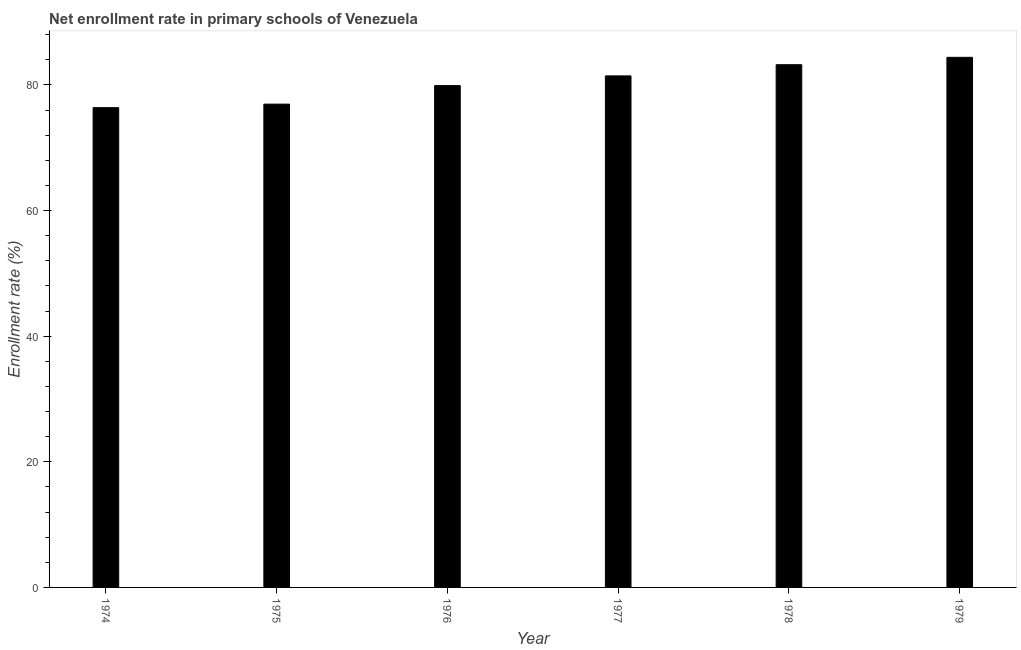Does the graph contain any zero values?
Provide a succinct answer. No. What is the title of the graph?
Your response must be concise. Net enrollment rate in primary schools of Venezuela. What is the label or title of the X-axis?
Give a very brief answer. Year. What is the label or title of the Y-axis?
Provide a short and direct response. Enrollment rate (%). What is the net enrollment rate in primary schools in 1974?
Your answer should be very brief. 76.38. Across all years, what is the maximum net enrollment rate in primary schools?
Provide a succinct answer. 84.39. Across all years, what is the minimum net enrollment rate in primary schools?
Give a very brief answer. 76.38. In which year was the net enrollment rate in primary schools maximum?
Ensure brevity in your answer.  1979. In which year was the net enrollment rate in primary schools minimum?
Provide a succinct answer. 1974. What is the sum of the net enrollment rate in primary schools?
Give a very brief answer. 482.26. What is the difference between the net enrollment rate in primary schools in 1975 and 1979?
Ensure brevity in your answer.  -7.45. What is the average net enrollment rate in primary schools per year?
Ensure brevity in your answer.  80.38. What is the median net enrollment rate in primary schools?
Your answer should be compact. 80.66. In how many years, is the net enrollment rate in primary schools greater than 68 %?
Ensure brevity in your answer.  6. Do a majority of the years between 1976 and 1979 (inclusive) have net enrollment rate in primary schools greater than 12 %?
Keep it short and to the point. Yes. Is the net enrollment rate in primary schools in 1976 less than that in 1977?
Offer a terse response. Yes. What is the difference between the highest and the second highest net enrollment rate in primary schools?
Ensure brevity in your answer.  1.18. Is the sum of the net enrollment rate in primary schools in 1978 and 1979 greater than the maximum net enrollment rate in primary schools across all years?
Offer a terse response. Yes. What is the difference between the highest and the lowest net enrollment rate in primary schools?
Your answer should be very brief. 8.01. In how many years, is the net enrollment rate in primary schools greater than the average net enrollment rate in primary schools taken over all years?
Make the answer very short. 3. How many bars are there?
Your response must be concise. 6. Are all the bars in the graph horizontal?
Give a very brief answer. No. What is the Enrollment rate (%) of 1974?
Your response must be concise. 76.38. What is the Enrollment rate (%) of 1975?
Ensure brevity in your answer.  76.94. What is the Enrollment rate (%) of 1976?
Provide a short and direct response. 79.89. What is the Enrollment rate (%) in 1977?
Ensure brevity in your answer.  81.44. What is the Enrollment rate (%) in 1978?
Give a very brief answer. 83.22. What is the Enrollment rate (%) in 1979?
Your answer should be compact. 84.39. What is the difference between the Enrollment rate (%) in 1974 and 1975?
Your response must be concise. -0.56. What is the difference between the Enrollment rate (%) in 1974 and 1976?
Offer a terse response. -3.51. What is the difference between the Enrollment rate (%) in 1974 and 1977?
Your answer should be very brief. -5.06. What is the difference between the Enrollment rate (%) in 1974 and 1978?
Offer a very short reply. -6.84. What is the difference between the Enrollment rate (%) in 1974 and 1979?
Ensure brevity in your answer.  -8.01. What is the difference between the Enrollment rate (%) in 1975 and 1976?
Keep it short and to the point. -2.95. What is the difference between the Enrollment rate (%) in 1975 and 1977?
Provide a short and direct response. -4.5. What is the difference between the Enrollment rate (%) in 1975 and 1978?
Your response must be concise. -6.28. What is the difference between the Enrollment rate (%) in 1975 and 1979?
Your answer should be compact. -7.45. What is the difference between the Enrollment rate (%) in 1976 and 1977?
Make the answer very short. -1.55. What is the difference between the Enrollment rate (%) in 1976 and 1978?
Offer a terse response. -3.33. What is the difference between the Enrollment rate (%) in 1976 and 1979?
Keep it short and to the point. -4.5. What is the difference between the Enrollment rate (%) in 1977 and 1978?
Provide a succinct answer. -1.78. What is the difference between the Enrollment rate (%) in 1977 and 1979?
Offer a very short reply. -2.96. What is the difference between the Enrollment rate (%) in 1978 and 1979?
Provide a succinct answer. -1.18. What is the ratio of the Enrollment rate (%) in 1974 to that in 1976?
Your answer should be compact. 0.96. What is the ratio of the Enrollment rate (%) in 1974 to that in 1977?
Keep it short and to the point. 0.94. What is the ratio of the Enrollment rate (%) in 1974 to that in 1978?
Offer a very short reply. 0.92. What is the ratio of the Enrollment rate (%) in 1974 to that in 1979?
Offer a terse response. 0.91. What is the ratio of the Enrollment rate (%) in 1975 to that in 1976?
Your answer should be very brief. 0.96. What is the ratio of the Enrollment rate (%) in 1975 to that in 1977?
Your answer should be compact. 0.94. What is the ratio of the Enrollment rate (%) in 1975 to that in 1978?
Give a very brief answer. 0.93. What is the ratio of the Enrollment rate (%) in 1975 to that in 1979?
Keep it short and to the point. 0.91. What is the ratio of the Enrollment rate (%) in 1976 to that in 1978?
Make the answer very short. 0.96. What is the ratio of the Enrollment rate (%) in 1976 to that in 1979?
Your response must be concise. 0.95. What is the ratio of the Enrollment rate (%) in 1977 to that in 1979?
Offer a very short reply. 0.96. What is the ratio of the Enrollment rate (%) in 1978 to that in 1979?
Offer a terse response. 0.99. 